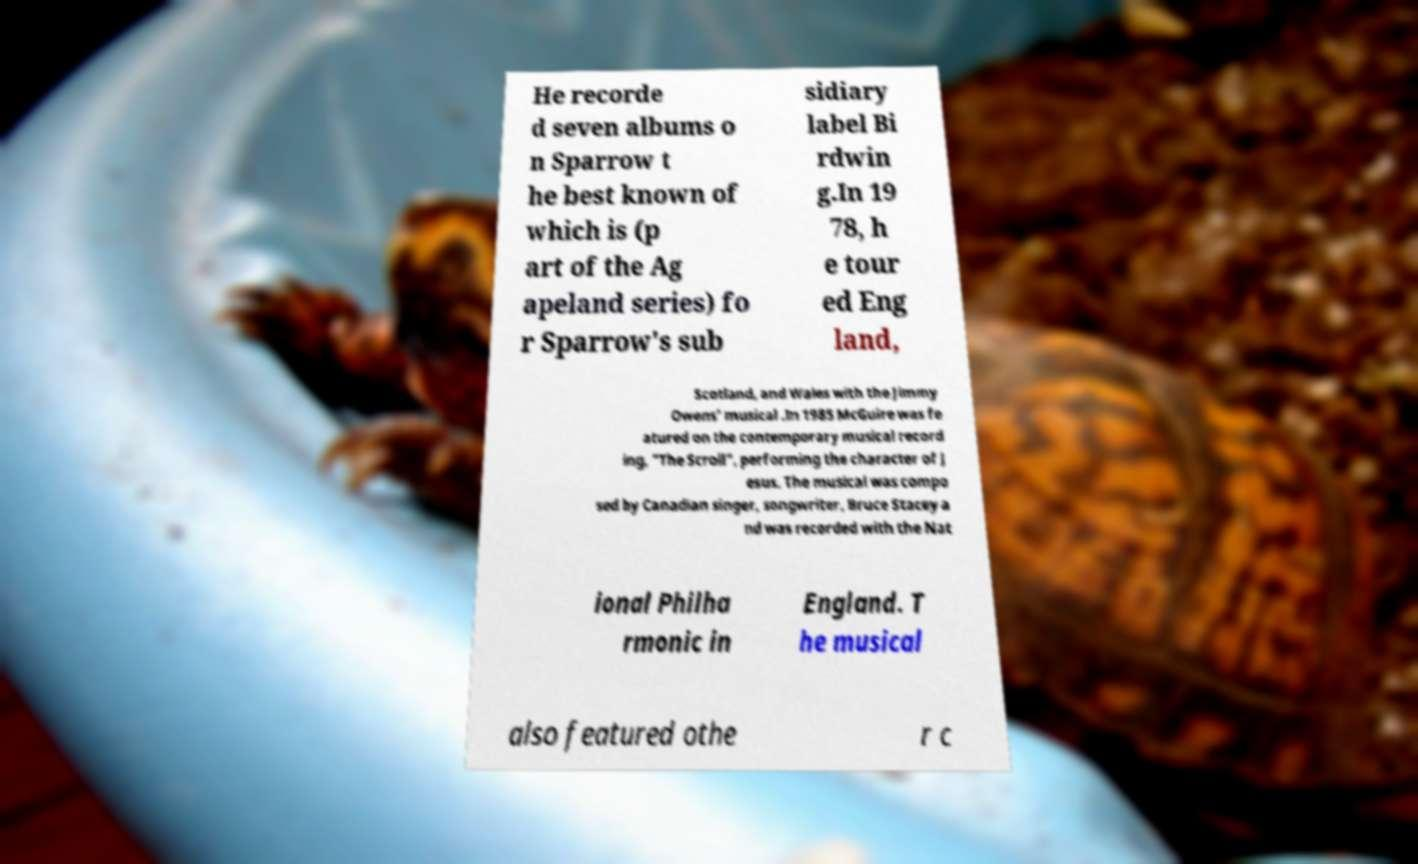Can you read and provide the text displayed in the image?This photo seems to have some interesting text. Can you extract and type it out for me? He recorde d seven albums o n Sparrow t he best known of which is (p art of the Ag apeland series) fo r Sparrow's sub sidiary label Bi rdwin g.In 19 78, h e tour ed Eng land, Scotland, and Wales with the Jimmy Owens' musical .In 1985 McGuire was fe atured on the contemporary musical record ing, "The Scroll", performing the character of J esus. The musical was compo sed by Canadian singer, songwriter, Bruce Stacey a nd was recorded with the Nat ional Philha rmonic in England. T he musical also featured othe r c 